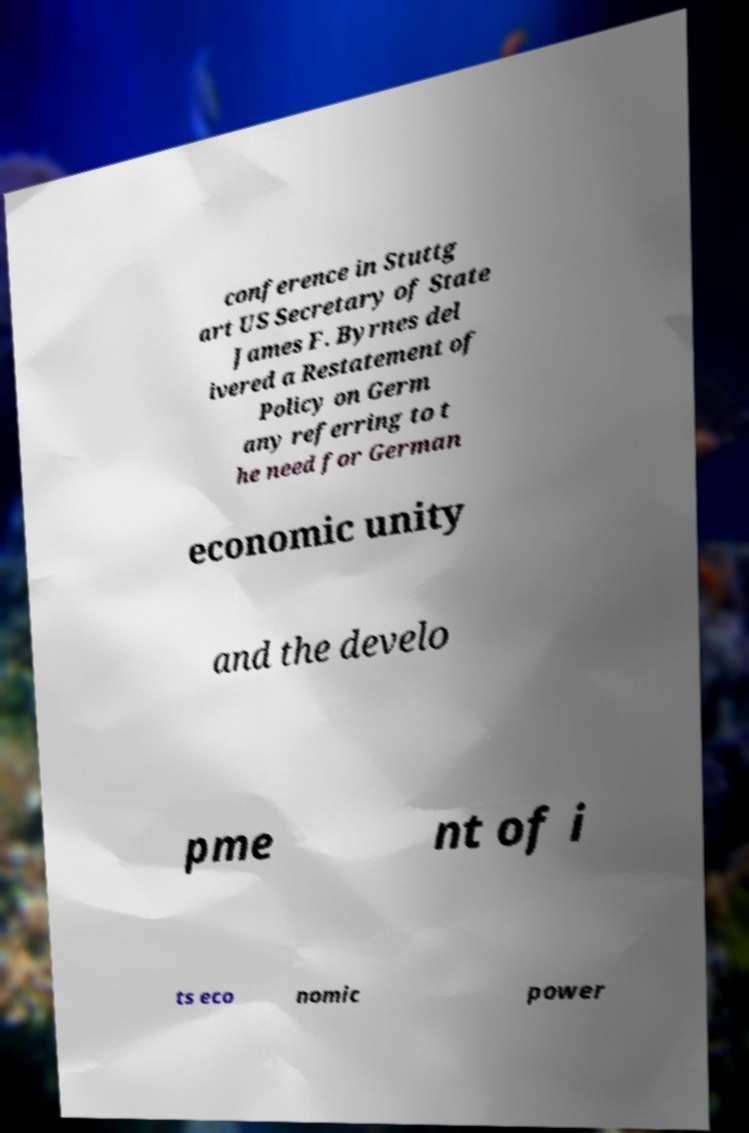Can you read and provide the text displayed in the image?This photo seems to have some interesting text. Can you extract and type it out for me? conference in Stuttg art US Secretary of State James F. Byrnes del ivered a Restatement of Policy on Germ any referring to t he need for German economic unity and the develo pme nt of i ts eco nomic power 